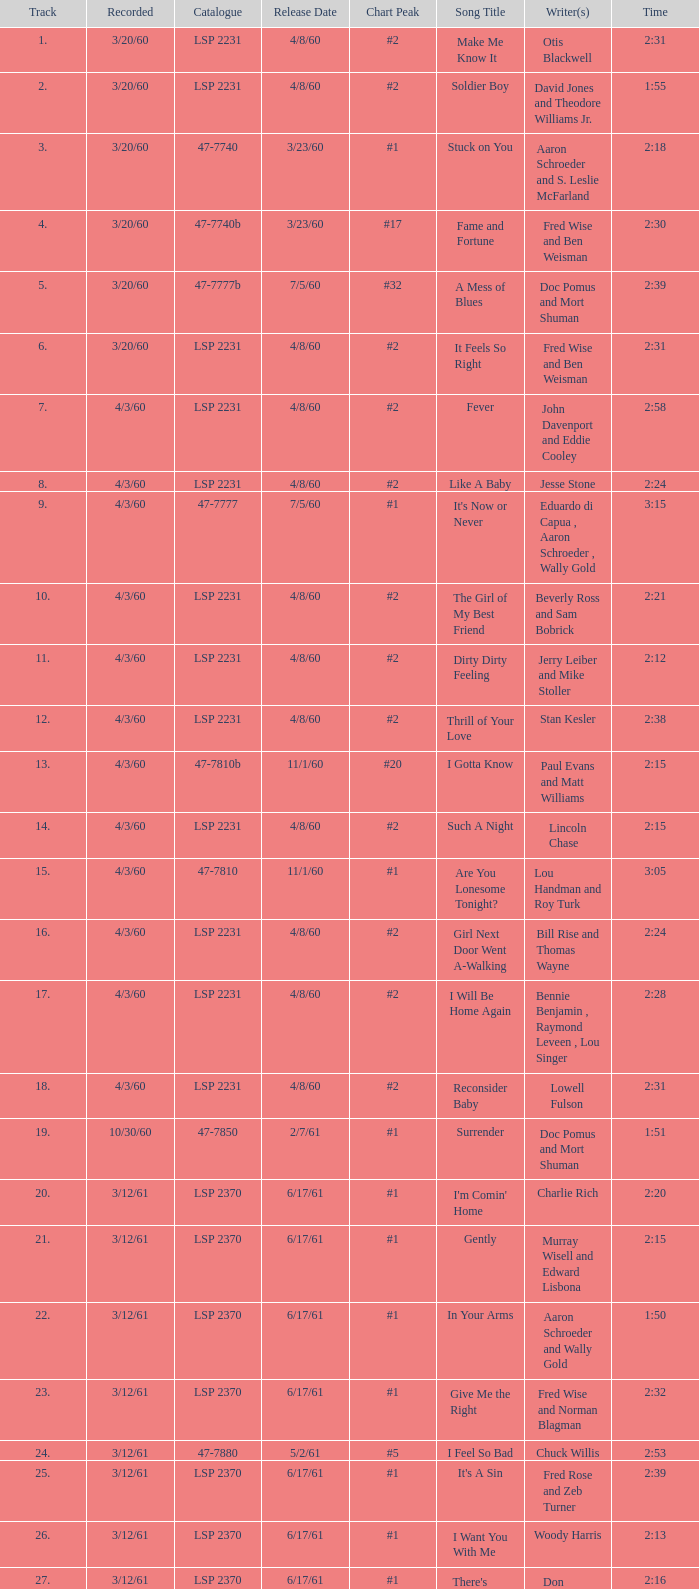How long are the songs composed by aaron schroeder and wally gold? 1:50. 